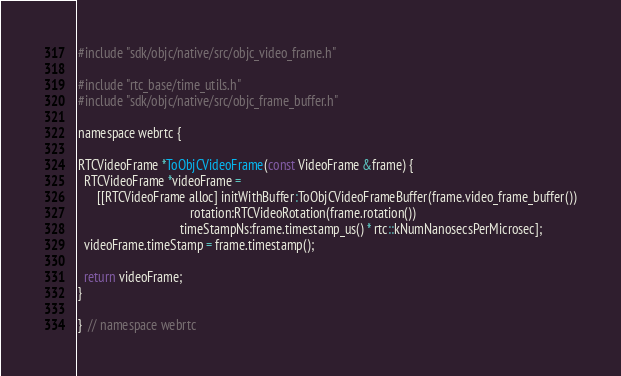<code> <loc_0><loc_0><loc_500><loc_500><_ObjectiveC_>#include "sdk/objc/native/src/objc_video_frame.h"

#include "rtc_base/time_utils.h"
#include "sdk/objc/native/src/objc_frame_buffer.h"

namespace webrtc {

RTCVideoFrame *ToObjCVideoFrame(const VideoFrame &frame) {
  RTCVideoFrame *videoFrame =
      [[RTCVideoFrame alloc] initWithBuffer:ToObjCVideoFrameBuffer(frame.video_frame_buffer())
                                   rotation:RTCVideoRotation(frame.rotation())
                                timeStampNs:frame.timestamp_us() * rtc::kNumNanosecsPerMicrosec];
  videoFrame.timeStamp = frame.timestamp();

  return videoFrame;
}

}  // namespace webrtc
</code> 